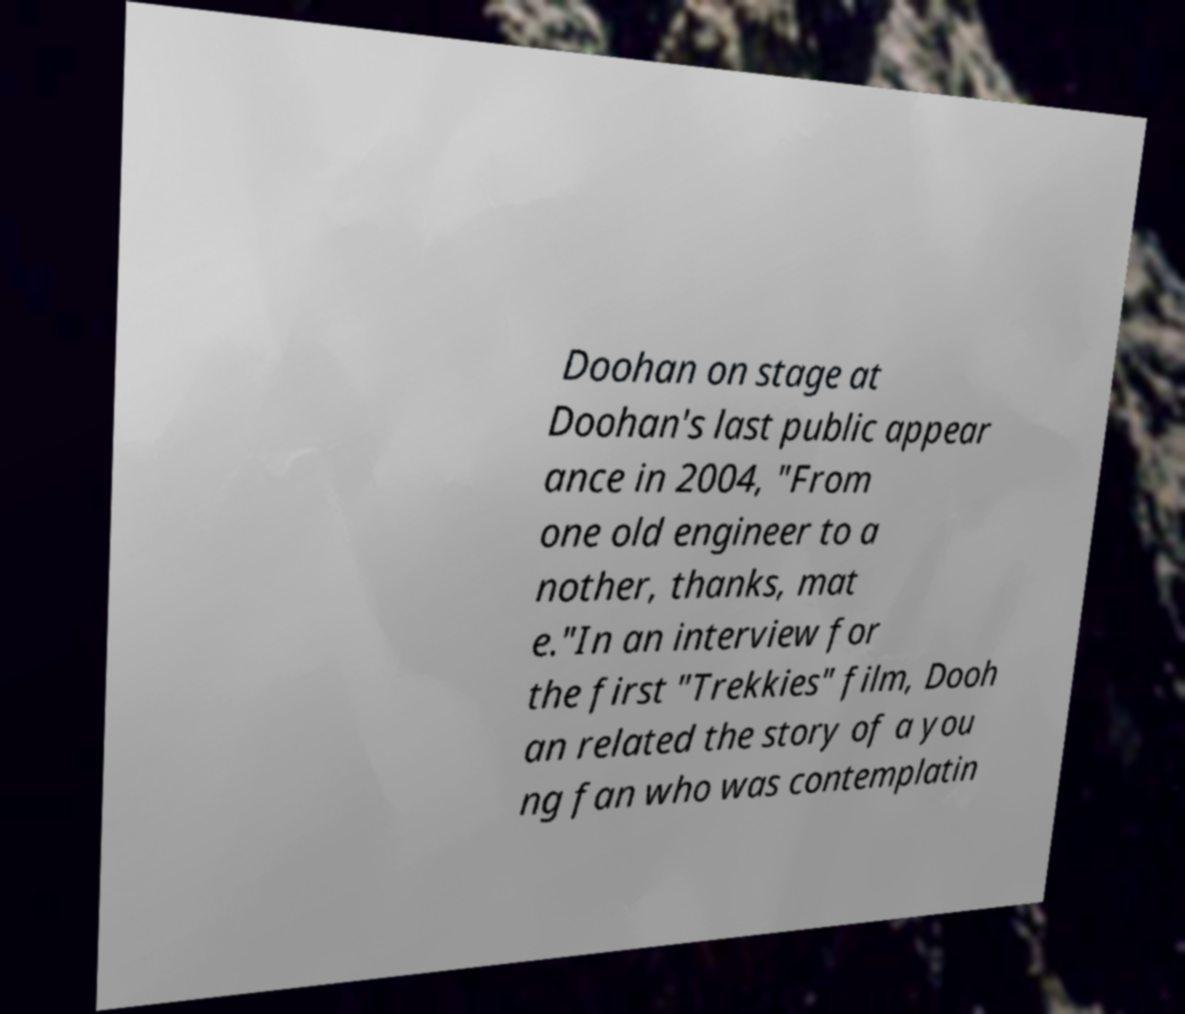What messages or text are displayed in this image? I need them in a readable, typed format. Doohan on stage at Doohan's last public appear ance in 2004, "From one old engineer to a nother, thanks, mat e."In an interview for the first "Trekkies" film, Dooh an related the story of a you ng fan who was contemplatin 